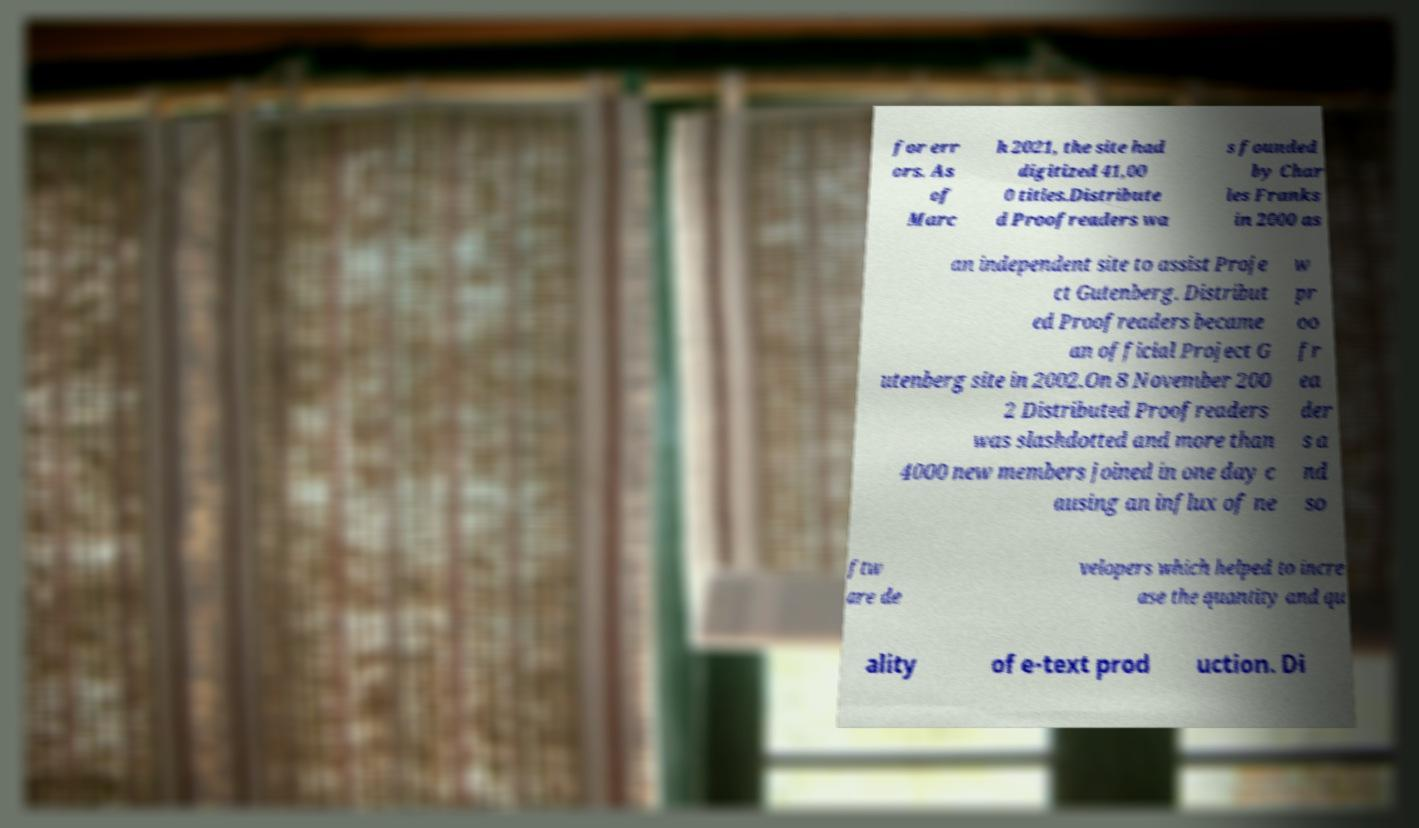Please identify and transcribe the text found in this image. for err ors. As of Marc h 2021, the site had digitized 41,00 0 titles.Distribute d Proofreaders wa s founded by Char les Franks in 2000 as an independent site to assist Proje ct Gutenberg. Distribut ed Proofreaders became an official Project G utenberg site in 2002.On 8 November 200 2 Distributed Proofreaders was slashdotted and more than 4000 new members joined in one day c ausing an influx of ne w pr oo fr ea der s a nd so ftw are de velopers which helped to incre ase the quantity and qu ality of e-text prod uction. Di 